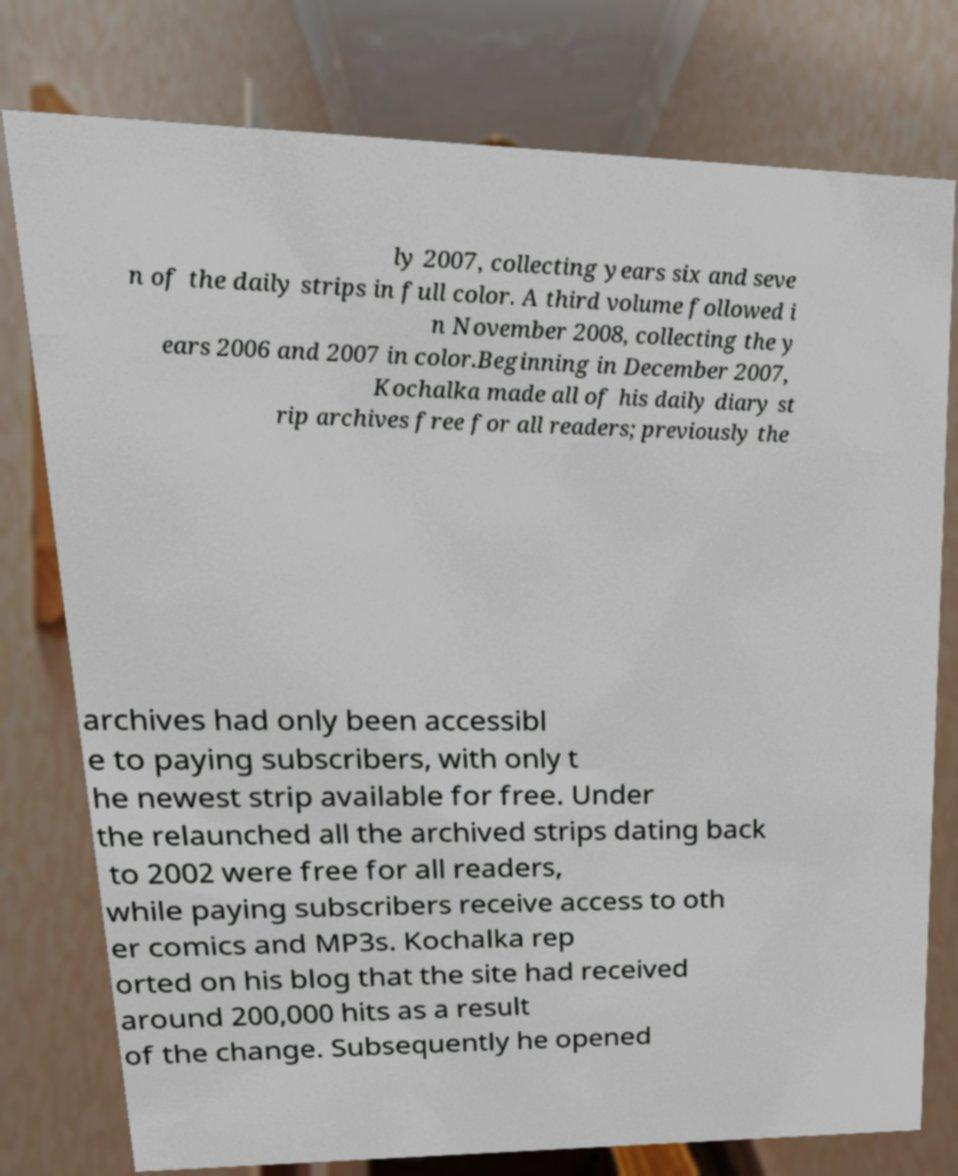Can you read and provide the text displayed in the image?This photo seems to have some interesting text. Can you extract and type it out for me? ly 2007, collecting years six and seve n of the daily strips in full color. A third volume followed i n November 2008, collecting the y ears 2006 and 2007 in color.Beginning in December 2007, Kochalka made all of his daily diary st rip archives free for all readers; previously the archives had only been accessibl e to paying subscribers, with only t he newest strip available for free. Under the relaunched all the archived strips dating back to 2002 were free for all readers, while paying subscribers receive access to oth er comics and MP3s. Kochalka rep orted on his blog that the site had received around 200,000 hits as a result of the change. Subsequently he opened 